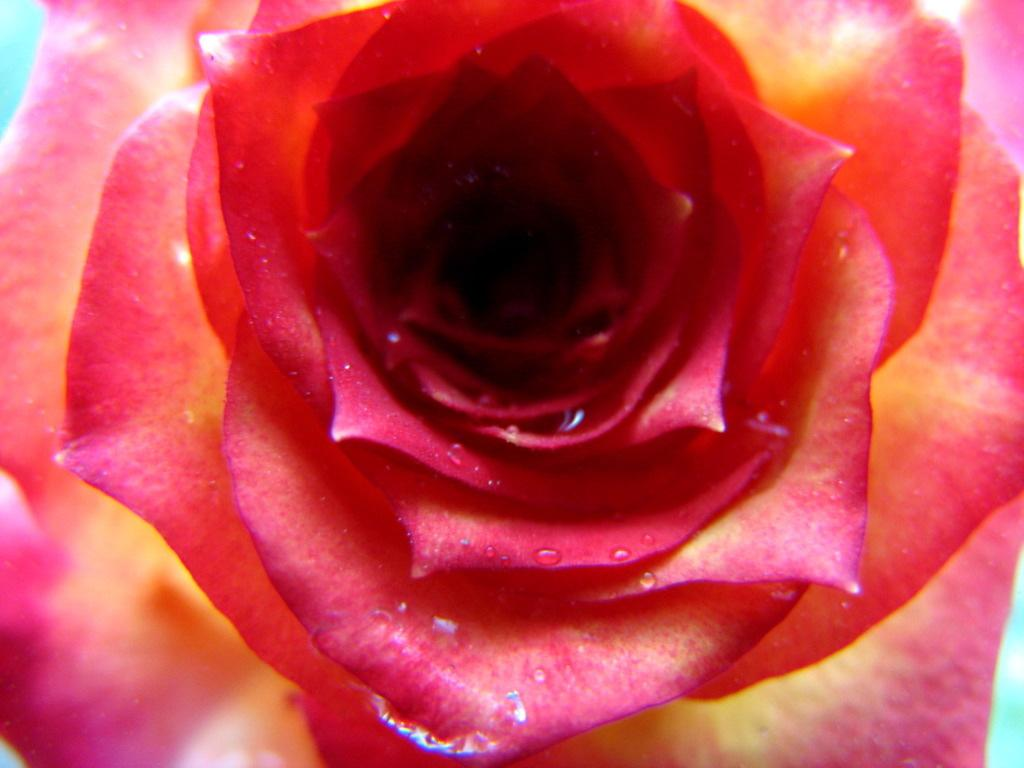What type of flower is in the image? There is a rose flower in the image. Can you describe the appearance of the rose flower? The rose flower has water droplets on its petals. What type of toad can be seen sitting on the truck in the image? There is no toad or truck present in the image; it only features a rose flower with water droplets on its petals. 